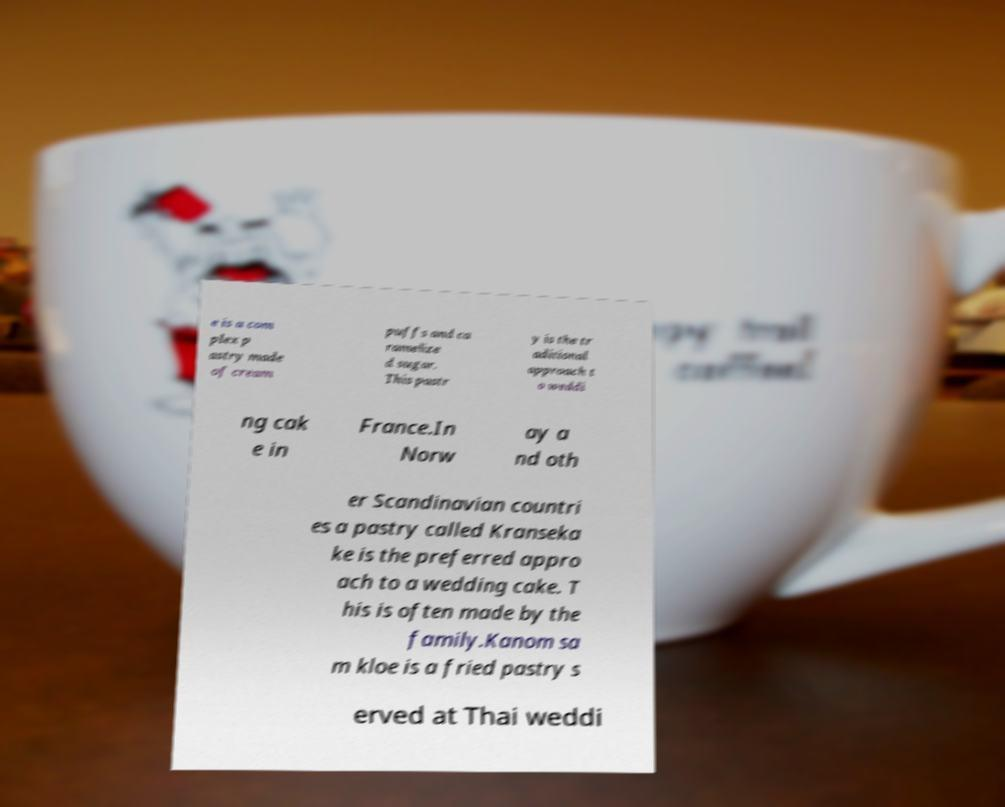Can you read and provide the text displayed in the image?This photo seems to have some interesting text. Can you extract and type it out for me? e is a com plex p astry made of cream puffs and ca ramelize d sugar. This pastr y is the tr aditional approach t o weddi ng cak e in France.In Norw ay a nd oth er Scandinavian countri es a pastry called Kranseka ke is the preferred appro ach to a wedding cake. T his is often made by the family.Kanom sa m kloe is a fried pastry s erved at Thai weddi 